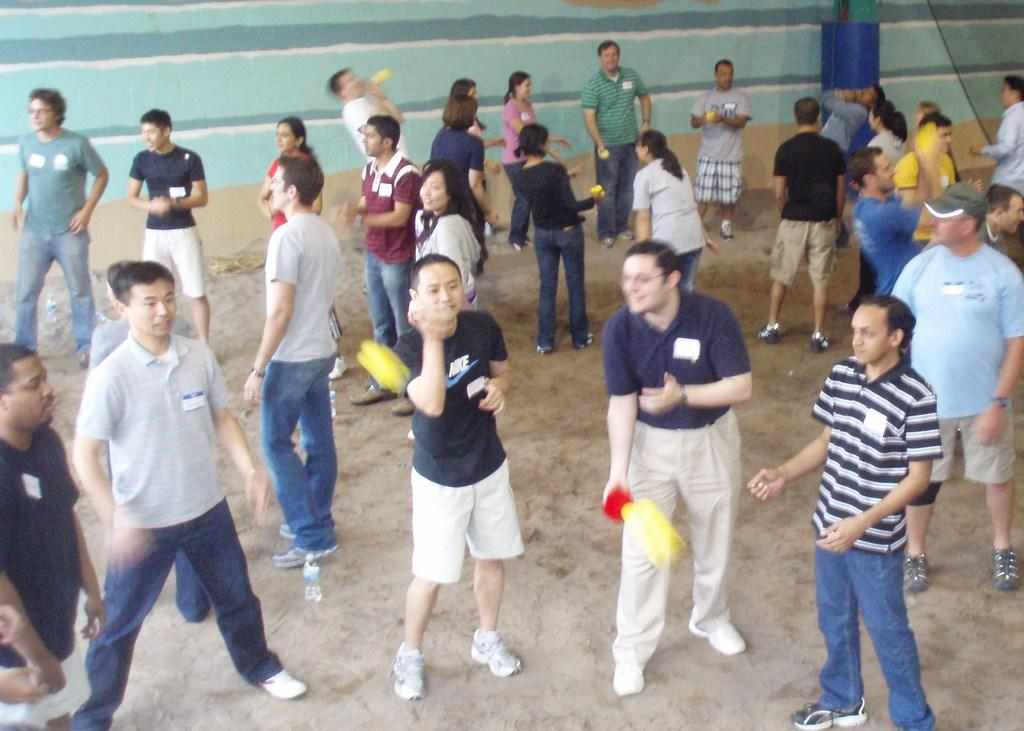What are the persons in the image doing? The persons in the image are standing and playing in the center of the image. What can be seen in the background of the image? There is a wall in the background of the image. What is the color of the wall? The wall is green in color. What is in front of the wall? There is a wire in front of the wall. Is there any snow visible in the image? No, there is no snow present in the image. Can you see the person's father in the image? There is no information about the person's father in the image or the provided facts. --- Facts: 1. There is a person sitting on a chair in the image. 2. The person is holding a book. 3. The book has a red cover. 4. There is a table next to the chair. 5. There is a lamp on the table. Absurd Topics: horse, ocean, volcano Conversation: What is the person in the image doing? The person in the image is sitting on a chair. What is the person holding in the image? The person is holding a book. What is the color of the book's cover? The book has a red cover. What is located next to the chair in the image? There is a table next to the chair. What is on the table in the image? There is a lamp on the table. Reasoning: Let's think step by step in order to produce the conversation. We start by identifying the main subject in the image, which is the person sitting on a chair. Then, we describe what the person is holding, which is a book with a red cover. Next, we mention the presence of a table next to the chair and a lamp on the table. Each question is designed to elicit a specific detail about the image that is known from the provided facts. Absurd Question/Answer: Can you see any horses or oceans in the image? No, there are no horses or oceans present in the image. Is the person's father in the image? There is no information about the person's father in the image or the provided facts. 